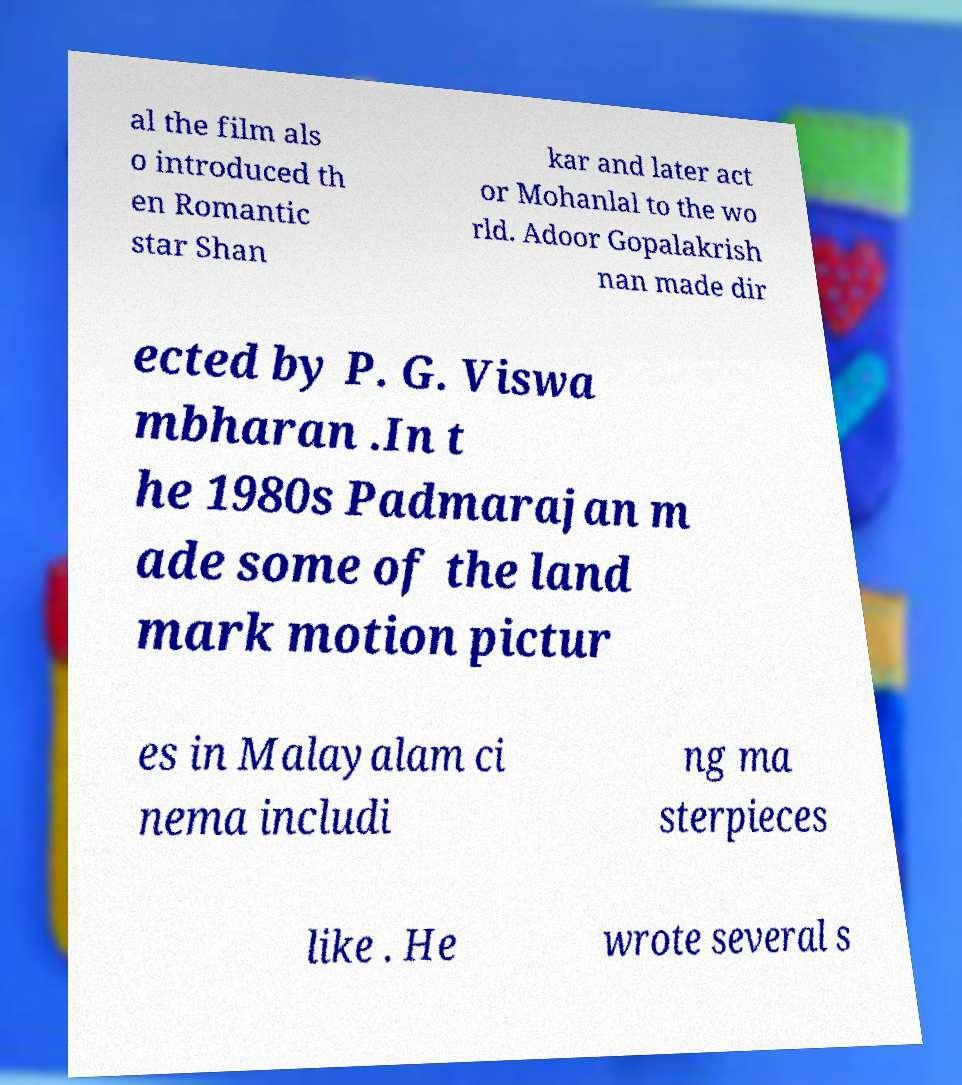Could you extract and type out the text from this image? al the film als o introduced th en Romantic star Shan kar and later act or Mohanlal to the wo rld. Adoor Gopalakrish nan made dir ected by P. G. Viswa mbharan .In t he 1980s Padmarajan m ade some of the land mark motion pictur es in Malayalam ci nema includi ng ma sterpieces like . He wrote several s 